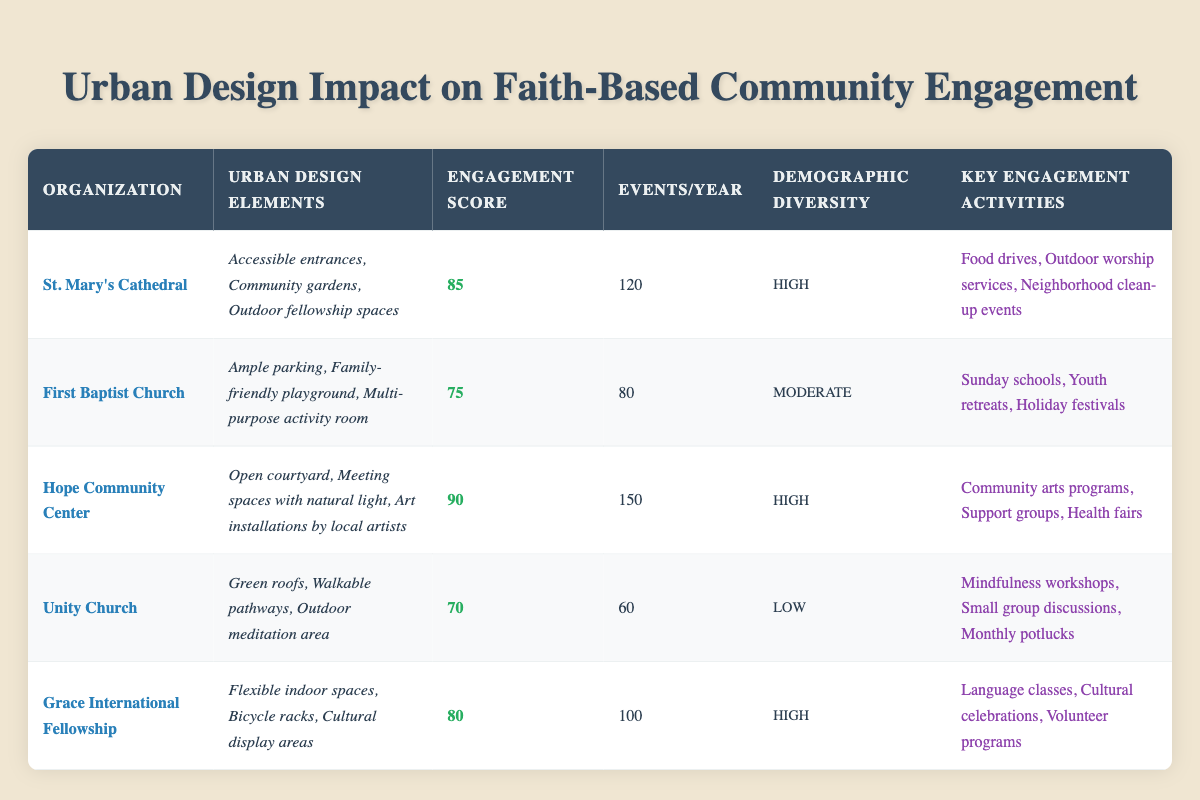What is the community engagement score of Hope Community Center? The community engagement score for Hope Community Center is listed in the table as 90.
Answer: 90 Which faith-based organization hosts the most events per year? By reviewing the events per year column, Hope Community Center has the highest number at 150 events.
Answer: Hope Community Center Is the demographic diversity of Unity Church high? The demographic diversity for Unity Church is categorized as low in the table, not high.
Answer: No What is the average community engagement score of the organizations listed? The scores are 85, 75, 90, 70, and 80. Summing these gives 400, and with 5 organizations, the average is 400/5 = 80.
Answer: 80 How many more events per year does St. Mary's Cathedral have compared to Unity Church? St. Mary's Cathedral has 120 events and Unity Church has 60 events. The difference is 120 - 60 = 60 events.
Answer: 60 Which organization has both high community engagement and high demographic diversity? St. Mary's Cathedral and Hope Community Center both have high community engagement scores (85 and 90) and high demographic diversity.
Answer: St. Mary's Cathedral and Hope Community Center What are the urban design elements of Grace International Fellowship? The urban design elements for Grace International Fellowship are flexible indoor spaces, bicycle racks, and cultural display areas, as shown in the table.
Answer: Flexible indoor spaces, bicycle racks, cultural display areas Does every organization listed have some form of outdoor space included in their urban design elements? Checking each organization, Unity Church has outdoor meditation areas, St. Mary's has outdoor fellowship spaces, and Hope Community Center has an open courtyard, confirming that all have outdoor spaces.
Answer: Yes Which organization has the least events per year, and what is that number? The least number of events is with Unity Church, which has 60 events per year.
Answer: Unity Church, 60 events Can you list the key engagement activities of First Baptist Church? The key engagement activities for First Baptist Church are Sunday schools, youth retreats, and holiday festivals, as specified in the table.
Answer: Sunday schools, youth retreats, holiday festivals 